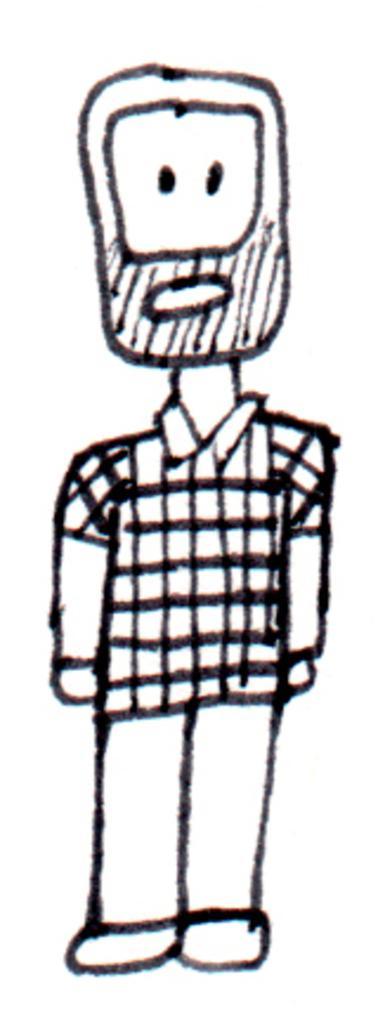Can you describe this image briefly? In the image we can see this is a drawing of a person. 